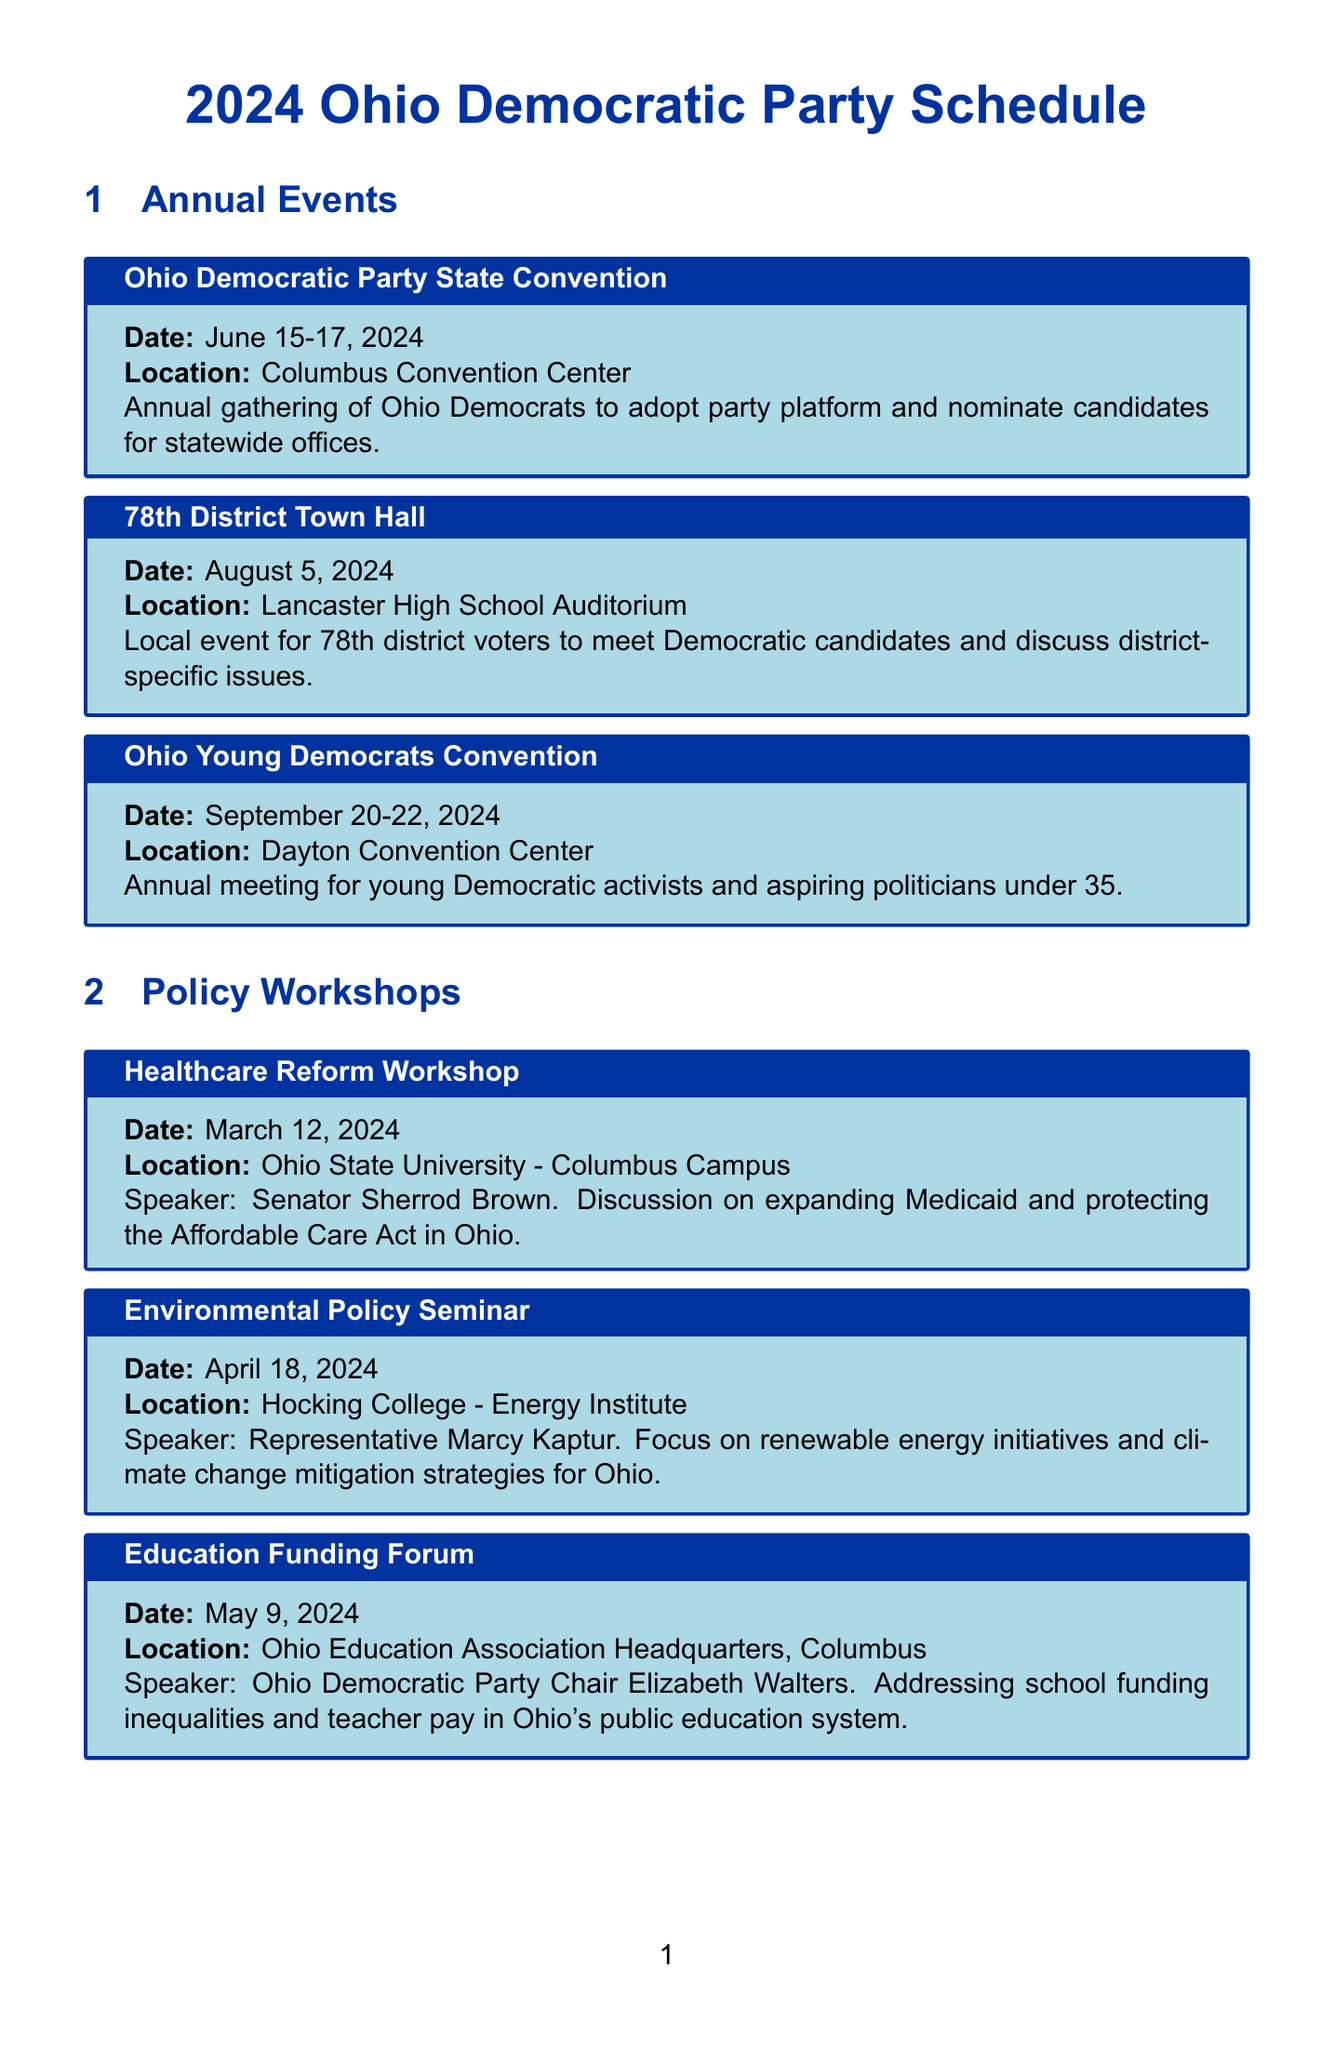What are the dates for the Ohio Democratic Party State Convention? The dates for the Ohio Democratic Party State Convention can be found in the annual events section of the document.
Answer: June 15-17, 2024 Where is the Environmental Policy Seminar being held? The location for the Environmental Policy Seminar is stated in the policy workshops section of the document.
Answer: Hocking College - Energy Institute Who is the speaker for the Education Funding Forum? The speaker for the Education Funding Forum is mentioned in the policy workshops section.
Answer: Ohio Democratic Party Chair Elizabeth Walters What recurring event takes place every first Saturday of the month? This information can be found in the grassroots activities section, which details ongoing community efforts.
Answer: Voter Registration Drive Which fundraising event is scheduled for October 5, 2024? The document specifies the name of the fundraising event that falls on this date.
Answer: Blue Ohio Gala How many days does the Ohio Young Democrats Convention last? The duration can be calculated from the provided dates in the annual events section.
Answer: 3 days Which event focuses on climate change mitigation strategies? This information is found in the description of the Environmental Policy Seminar in the policy workshops section.
Answer: Environmental Policy Seminar What is the location of the 78th District Town Hall? The town hall's location is provided in the annual events section of the document.
Answer: Lancaster High School Auditorium Which grassroots activity involves contacting voters? This information is described in the grassroots activities section, detailing specific volunteer tasks.
Answer: Phone Banking for 2024 Elections 